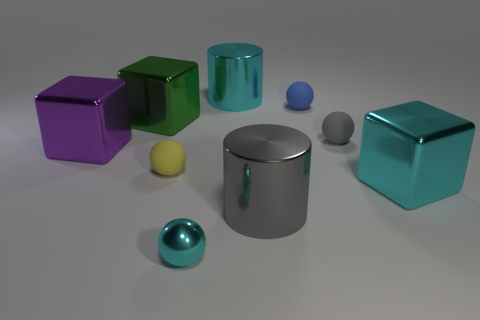Subtract all tiny yellow matte spheres. How many spheres are left? 3 Subtract all gray spheres. How many spheres are left? 3 Subtract 2 balls. How many balls are left? 2 Add 1 cubes. How many objects exist? 10 Subtract all green balls. Subtract all green cubes. How many balls are left? 4 Subtract all cubes. How many objects are left? 6 Subtract all big cyan things. Subtract all small gray things. How many objects are left? 6 Add 5 metallic cubes. How many metallic cubes are left? 8 Add 7 tiny purple shiny spheres. How many tiny purple shiny spheres exist? 7 Subtract 0 purple cylinders. How many objects are left? 9 